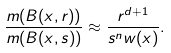<formula> <loc_0><loc_0><loc_500><loc_500>\frac { m ( B ( x , r ) ) } { m ( B ( x , s ) ) } \approx \frac { r ^ { d + 1 } } { s ^ { n } w ( x ) } .</formula> 